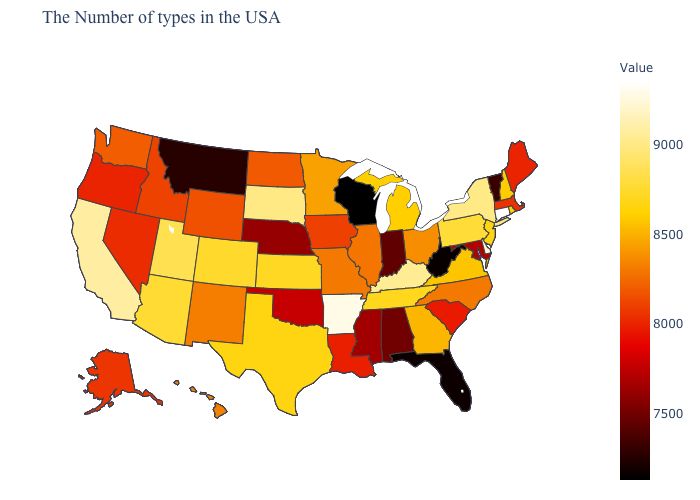Which states hav the highest value in the MidWest?
Write a very short answer. South Dakota. Among the states that border Wisconsin , which have the lowest value?
Quick response, please. Iowa. Does Georgia have a higher value than Kentucky?
Write a very short answer. No. Does Washington have a higher value than Florida?
Write a very short answer. Yes. Does Connecticut have the highest value in the Northeast?
Give a very brief answer. Yes. Which states hav the highest value in the West?
Quick response, please. California. 